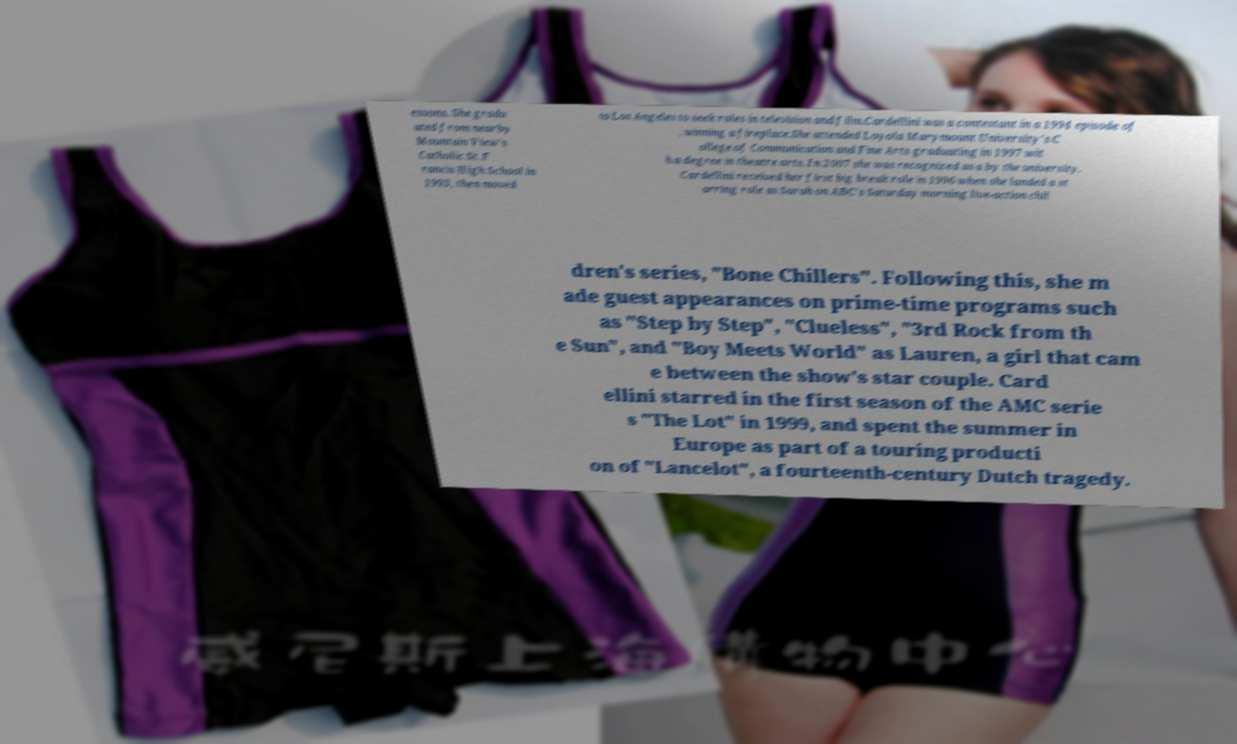Could you assist in decoding the text presented in this image and type it out clearly? essons. She gradu ated from nearby Mountain View's Catholic St. F rancis High School in 1993, then moved to Los Angeles to seek roles in television and film.Cardellini was a contestant in a 1994 episode of , winning a fireplace.She attended Loyola Marymount University's C ollege of Communication and Fine Arts graduating in 1997 wit h a degree in theatre arts. In 2007 she was recognized as a by the university. Cardellini received her first big break role in 1996 when she landed a st arring role as Sarah on ABC's Saturday morning live-action chil dren's series, "Bone Chillers". Following this, she m ade guest appearances on prime-time programs such as "Step by Step", "Clueless", "3rd Rock from th e Sun", and "Boy Meets World" as Lauren, a girl that cam e between the show's star couple. Card ellini starred in the first season of the AMC serie s "The Lot" in 1999, and spent the summer in Europe as part of a touring producti on of "Lancelot", a fourteenth-century Dutch tragedy. 